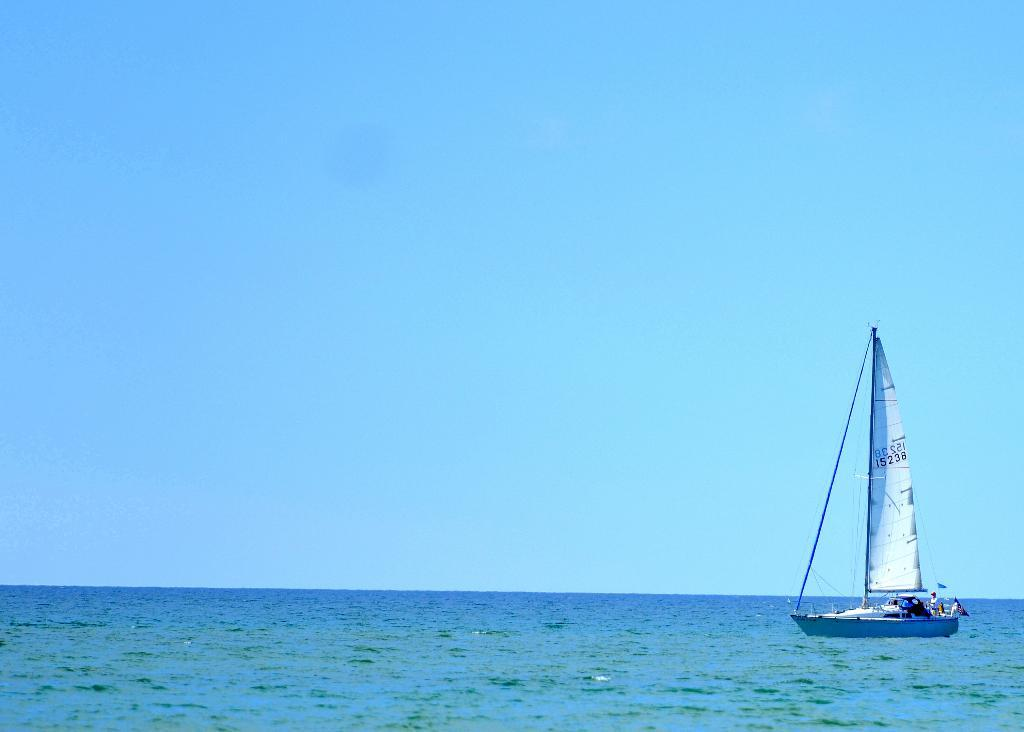What is the main subject of the image? The main subject of the image is a boat. Where is the boat located? The boat is on the water. What can be seen in the background of the image? The sky is visible in the background of the image. What type of shock can be seen in the image? There is no shock present in the image; it features a boat on the water with the sky visible in the background. 